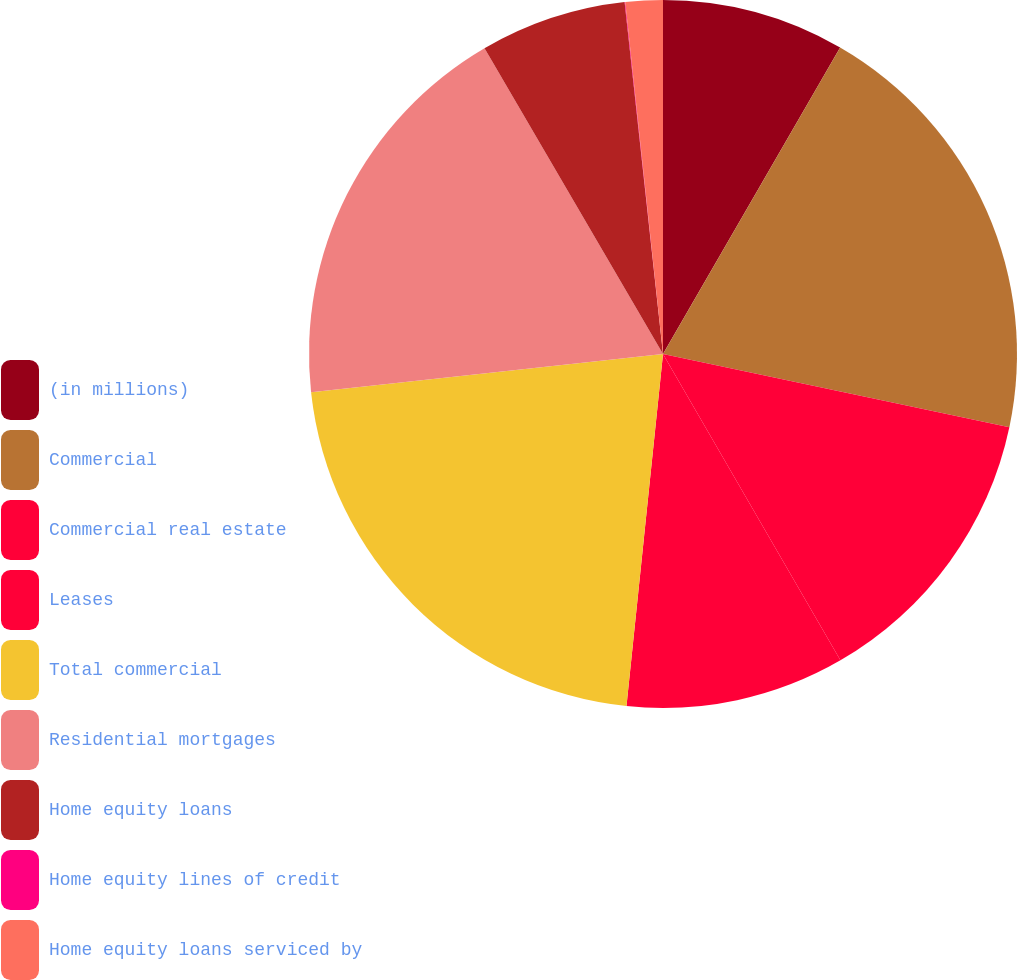<chart> <loc_0><loc_0><loc_500><loc_500><pie_chart><fcel>(in millions)<fcel>Commercial<fcel>Commercial real estate<fcel>Leases<fcel>Total commercial<fcel>Residential mortgages<fcel>Home equity loans<fcel>Home equity lines of credit<fcel>Home equity loans serviced by<nl><fcel>8.34%<fcel>19.97%<fcel>13.33%<fcel>10.0%<fcel>21.63%<fcel>18.31%<fcel>6.68%<fcel>0.03%<fcel>1.7%<nl></chart> 